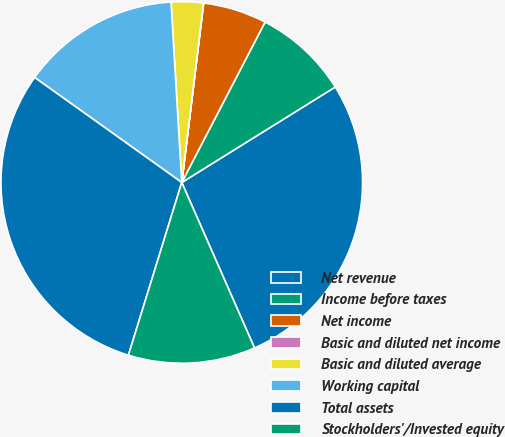Convert chart to OTSL. <chart><loc_0><loc_0><loc_500><loc_500><pie_chart><fcel>Net revenue<fcel>Income before taxes<fcel>Net income<fcel>Basic and diluted net income<fcel>Basic and diluted average<fcel>Working capital<fcel>Total assets<fcel>Stockholders'/Invested equity<nl><fcel>27.27%<fcel>8.52%<fcel>5.69%<fcel>0.02%<fcel>2.86%<fcel>14.19%<fcel>30.1%<fcel>11.36%<nl></chart> 